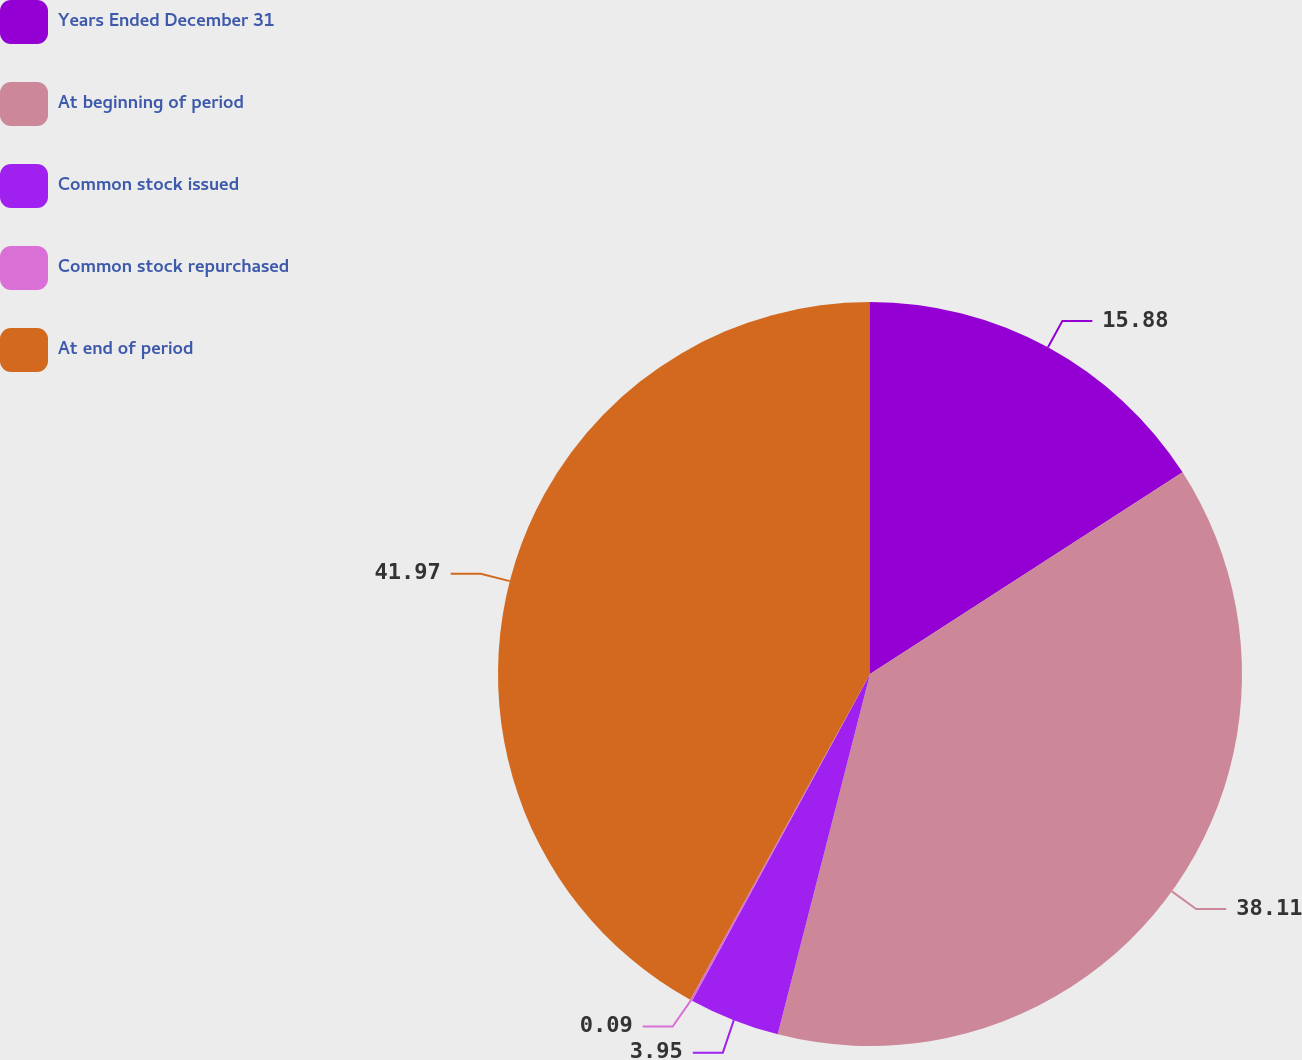Convert chart to OTSL. <chart><loc_0><loc_0><loc_500><loc_500><pie_chart><fcel>Years Ended December 31<fcel>At beginning of period<fcel>Common stock issued<fcel>Common stock repurchased<fcel>At end of period<nl><fcel>15.88%<fcel>38.11%<fcel>3.95%<fcel>0.09%<fcel>41.97%<nl></chart> 